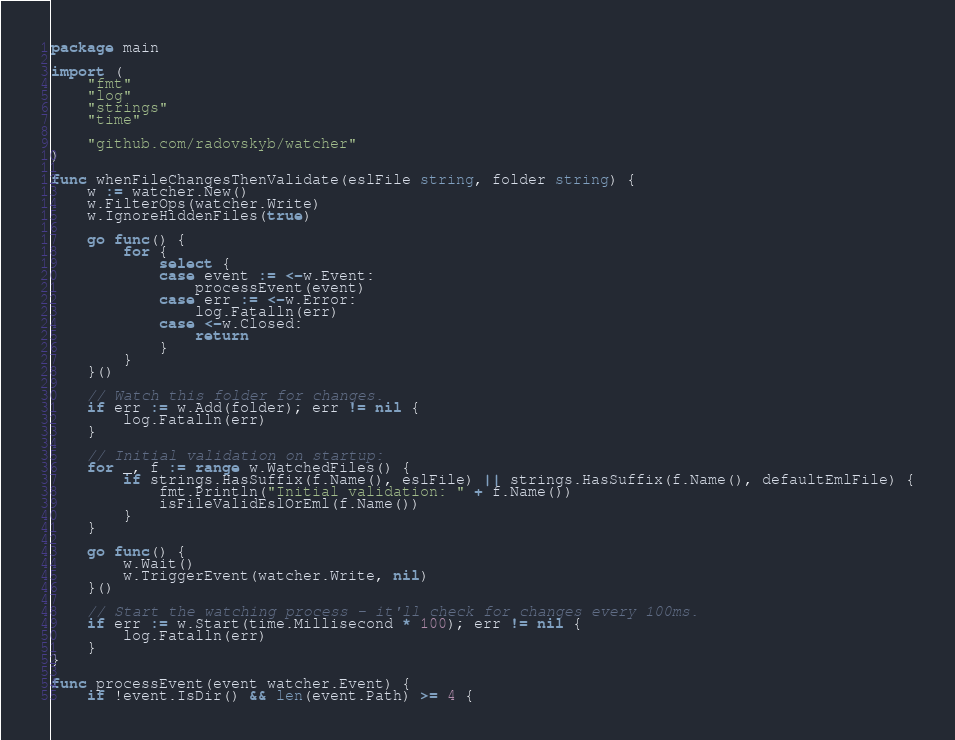Convert code to text. <code><loc_0><loc_0><loc_500><loc_500><_Go_>package main

import (
	"fmt"
	"log"
	"strings"
	"time"

	"github.com/radovskyb/watcher"
)

func whenFileChangesThenValidate(eslFile string, folder string) {
	w := watcher.New()
	w.FilterOps(watcher.Write)
	w.IgnoreHiddenFiles(true)

	go func() {
		for {
			select {
			case event := <-w.Event:
				processEvent(event)
			case err := <-w.Error:
				log.Fatalln(err)
			case <-w.Closed:
				return
			}
		}
	}()

	// Watch this folder for changes.
	if err := w.Add(folder); err != nil {
		log.Fatalln(err)
	}

	// Initial validation on startup:
	for _, f := range w.WatchedFiles() {
		if strings.HasSuffix(f.Name(), eslFile) || strings.HasSuffix(f.Name(), defaultEmlFile) {
			fmt.Println("Initial validation: " + f.Name())
			isFileValidEslOrEml(f.Name())
		}
	}

	go func() {
		w.Wait()
		w.TriggerEvent(watcher.Write, nil)
	}()

	// Start the watching process - it'll check for changes every 100ms.
	if err := w.Start(time.Millisecond * 100); err != nil {
		log.Fatalln(err)
	}
}

func processEvent(event watcher.Event) {
	if !event.IsDir() && len(event.Path) >= 4 {</code> 